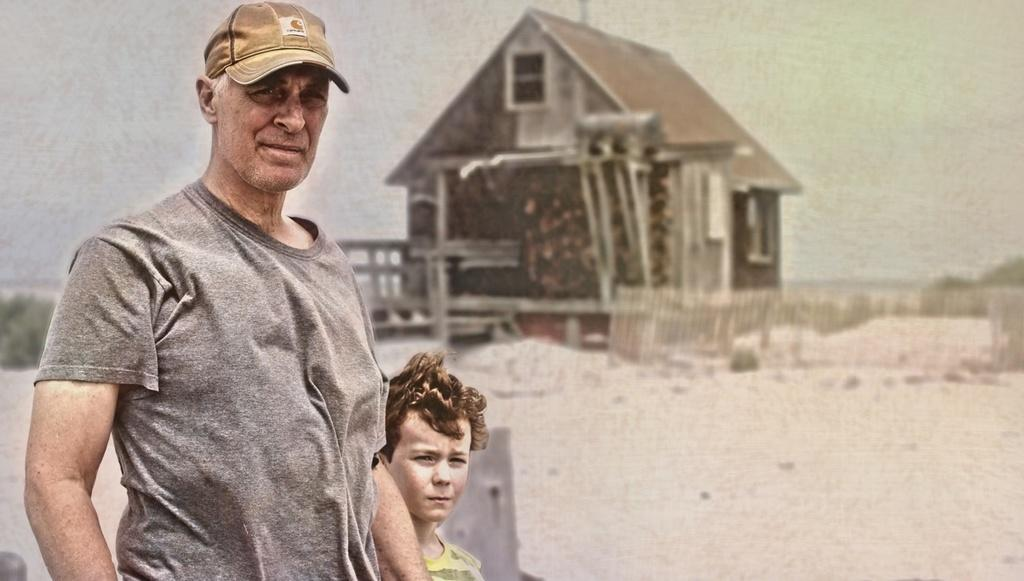Who can be seen standing in the image? There is a man and a child standing in the image. What is on the backside of the image? There is a picture of a house on the backside of the image. What type of barrier is present in the image? There is a wooden fence in the image. What type of vegetation is visible in the image? There are plants in the image. What is visible above the subjects in the image? The sky is visible in the image. What type of collar is the fowl wearing in the image? There is no fowl present in the image, and therefore no collar can be observed. What is the title of the image? The image does not have a title, as it is a photograph or illustration and not a piece of literature or artwork with a specific title. 